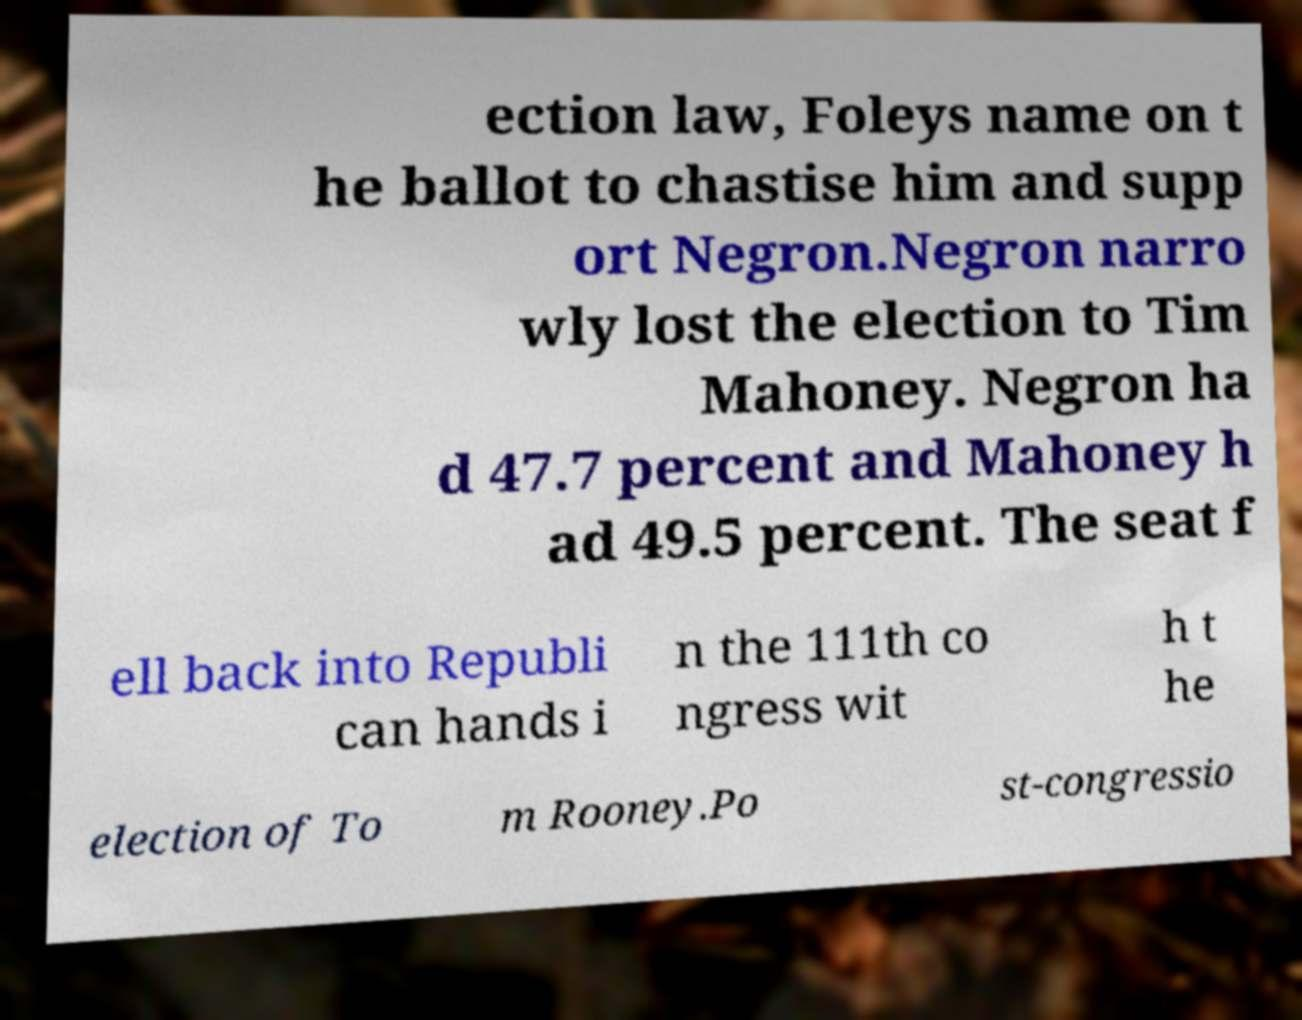Could you assist in decoding the text presented in this image and type it out clearly? ection law, Foleys name on t he ballot to chastise him and supp ort Negron.Negron narro wly lost the election to Tim Mahoney. Negron ha d 47.7 percent and Mahoney h ad 49.5 percent. The seat f ell back into Republi can hands i n the 111th co ngress wit h t he election of To m Rooney.Po st-congressio 